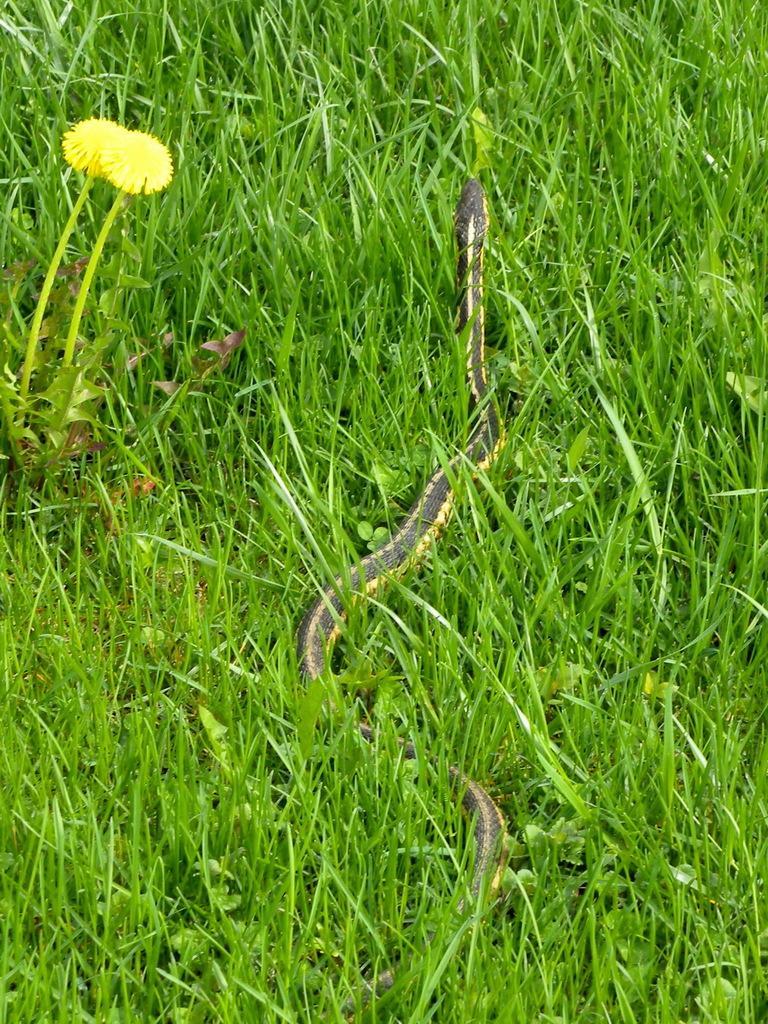Can you describe this image briefly? In this picture there is a snake in the center of the image and there is grassland around the area of the image, there are flowers on the left side of the image. 